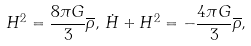Convert formula to latex. <formula><loc_0><loc_0><loc_500><loc_500>H ^ { 2 } = \frac { 8 \pi G } { 3 } \overline { \rho } , \, \dot { H } + H ^ { 2 } = - \frac { 4 \pi G } { 3 } \overline { \rho } ,</formula> 